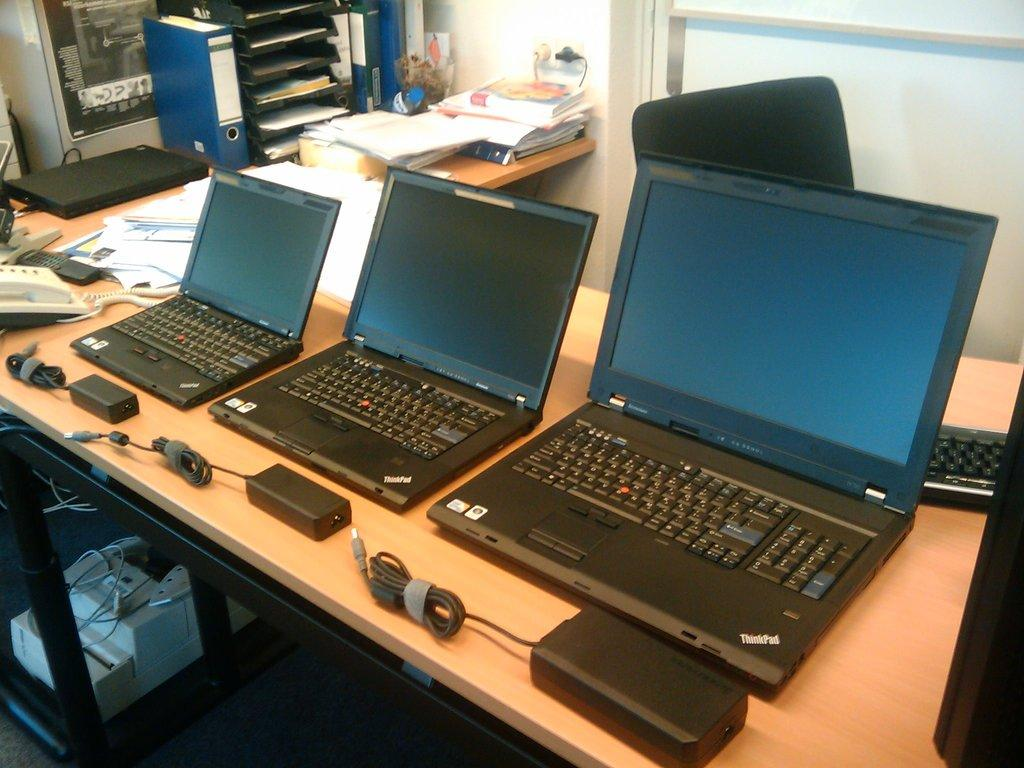<image>
Present a compact description of the photo's key features. Three ThinkPad laptops of varying sizes are sitting in a row. 